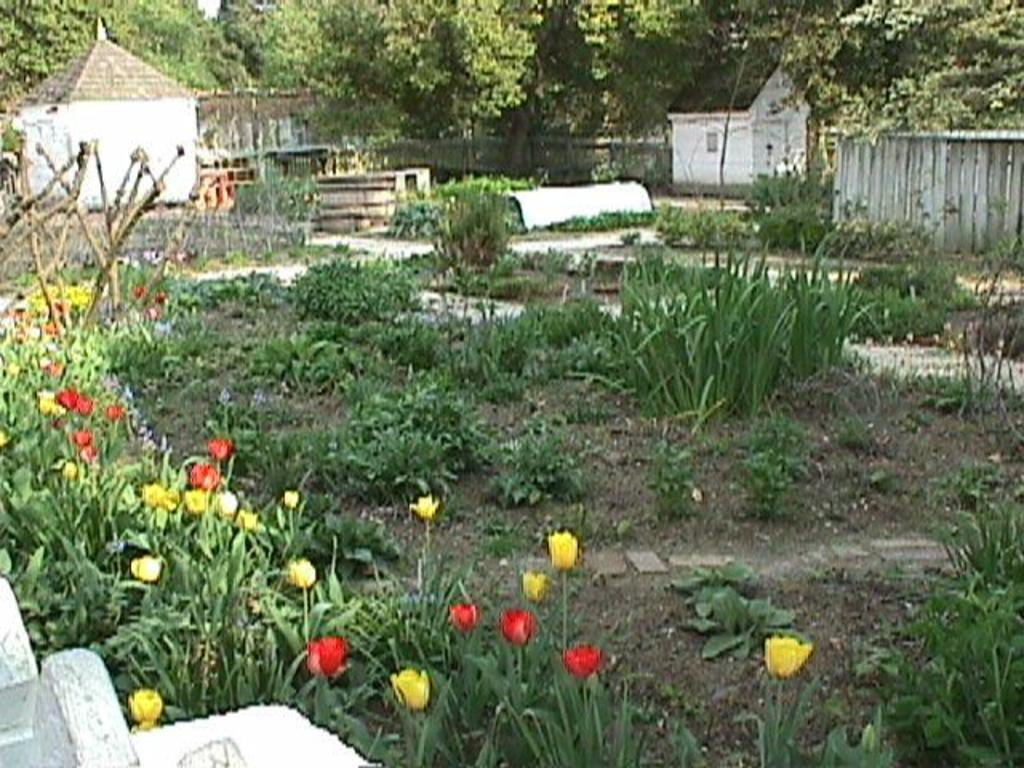Please provide a concise description of this image. In this image we can see few houses. There are many trees and plants in the image. There are many flowers to the plants in the image. There is a fence in the image. 